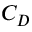<formula> <loc_0><loc_0><loc_500><loc_500>C _ { D }</formula> 